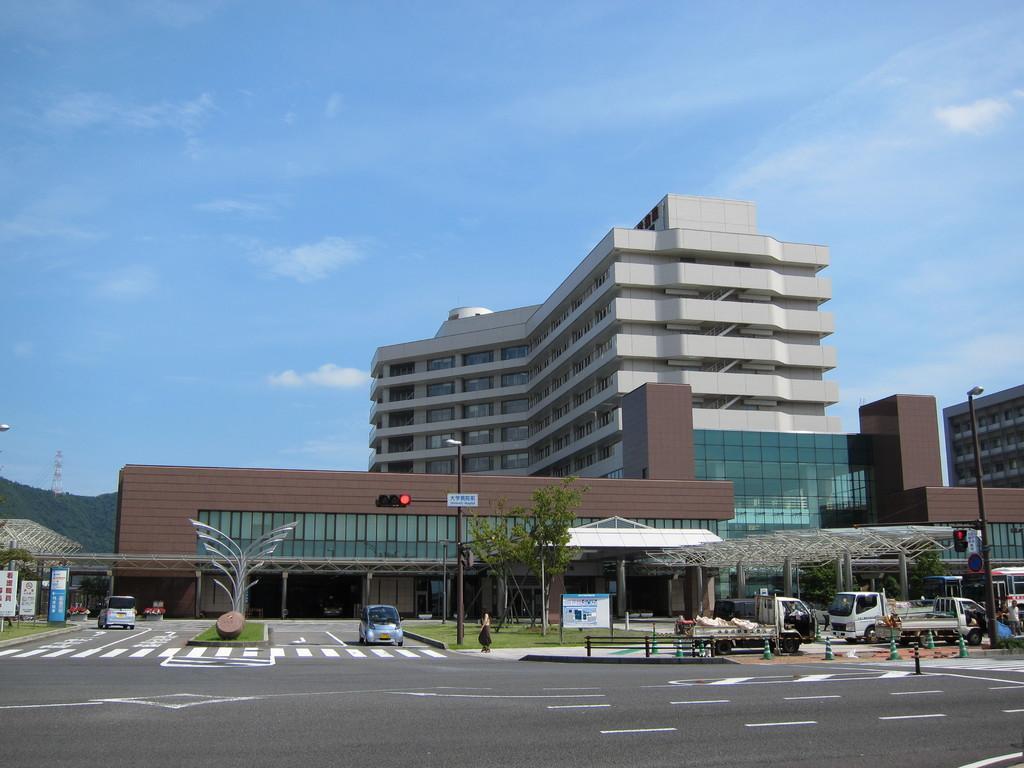In one or two sentences, can you explain what this image depicts? Here we can see buildings, poles, trees, vehicles, boards, cars, grass, and traffic cones. There is a road. In the background we can see a mountain, tower, and sky. 